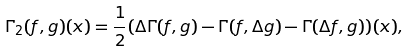<formula> <loc_0><loc_0><loc_500><loc_500>\Gamma _ { 2 } ( f , g ) ( x ) = \frac { 1 } { 2 } ( \Delta \Gamma ( f , g ) - \Gamma ( f , \Delta g ) - \Gamma ( \Delta f , g ) ) ( x ) ,</formula> 